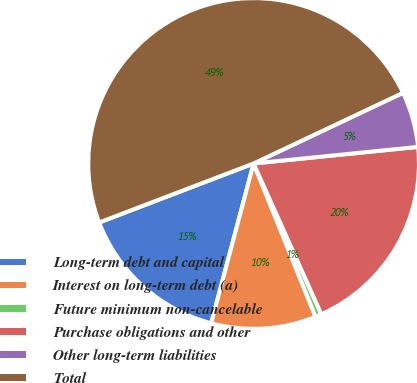Convert chart to OTSL. <chart><loc_0><loc_0><loc_500><loc_500><pie_chart><fcel>Long-term debt and capital<fcel>Interest on long-term debt (a)<fcel>Future minimum non-cancelable<fcel>Purchase obligations and other<fcel>Other long-term liabilities<fcel>Total<nl><fcel>15.06%<fcel>10.24%<fcel>0.61%<fcel>19.88%<fcel>5.43%<fcel>48.78%<nl></chart> 